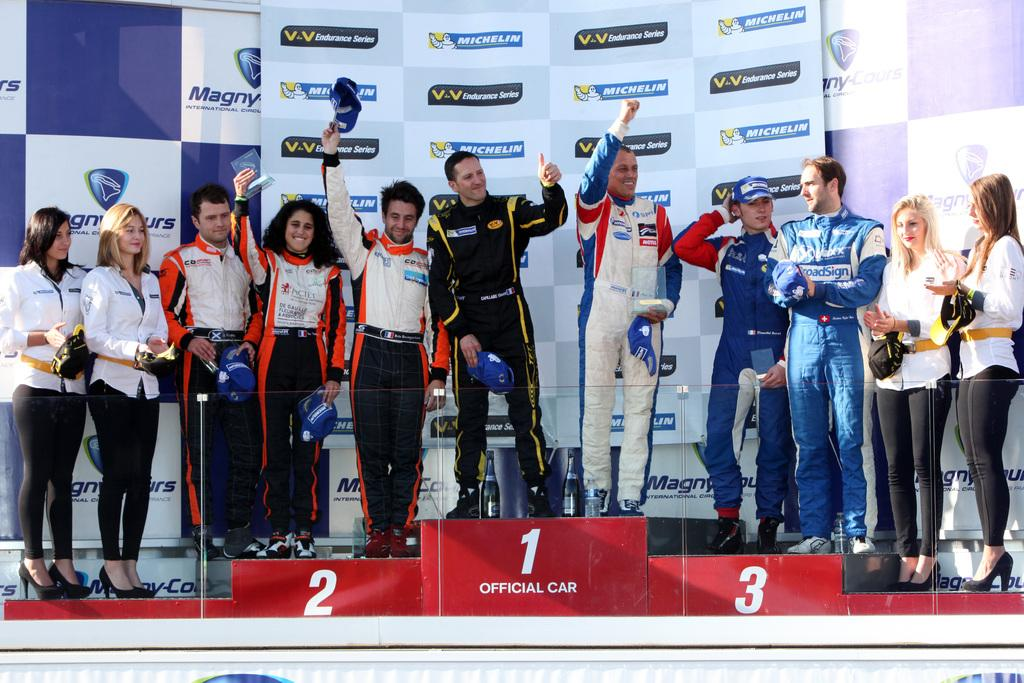<image>
Render a clear and concise summary of the photo. Racers take different spots in the winners area, with the number one spot labeled OFFICIAL CAR. 